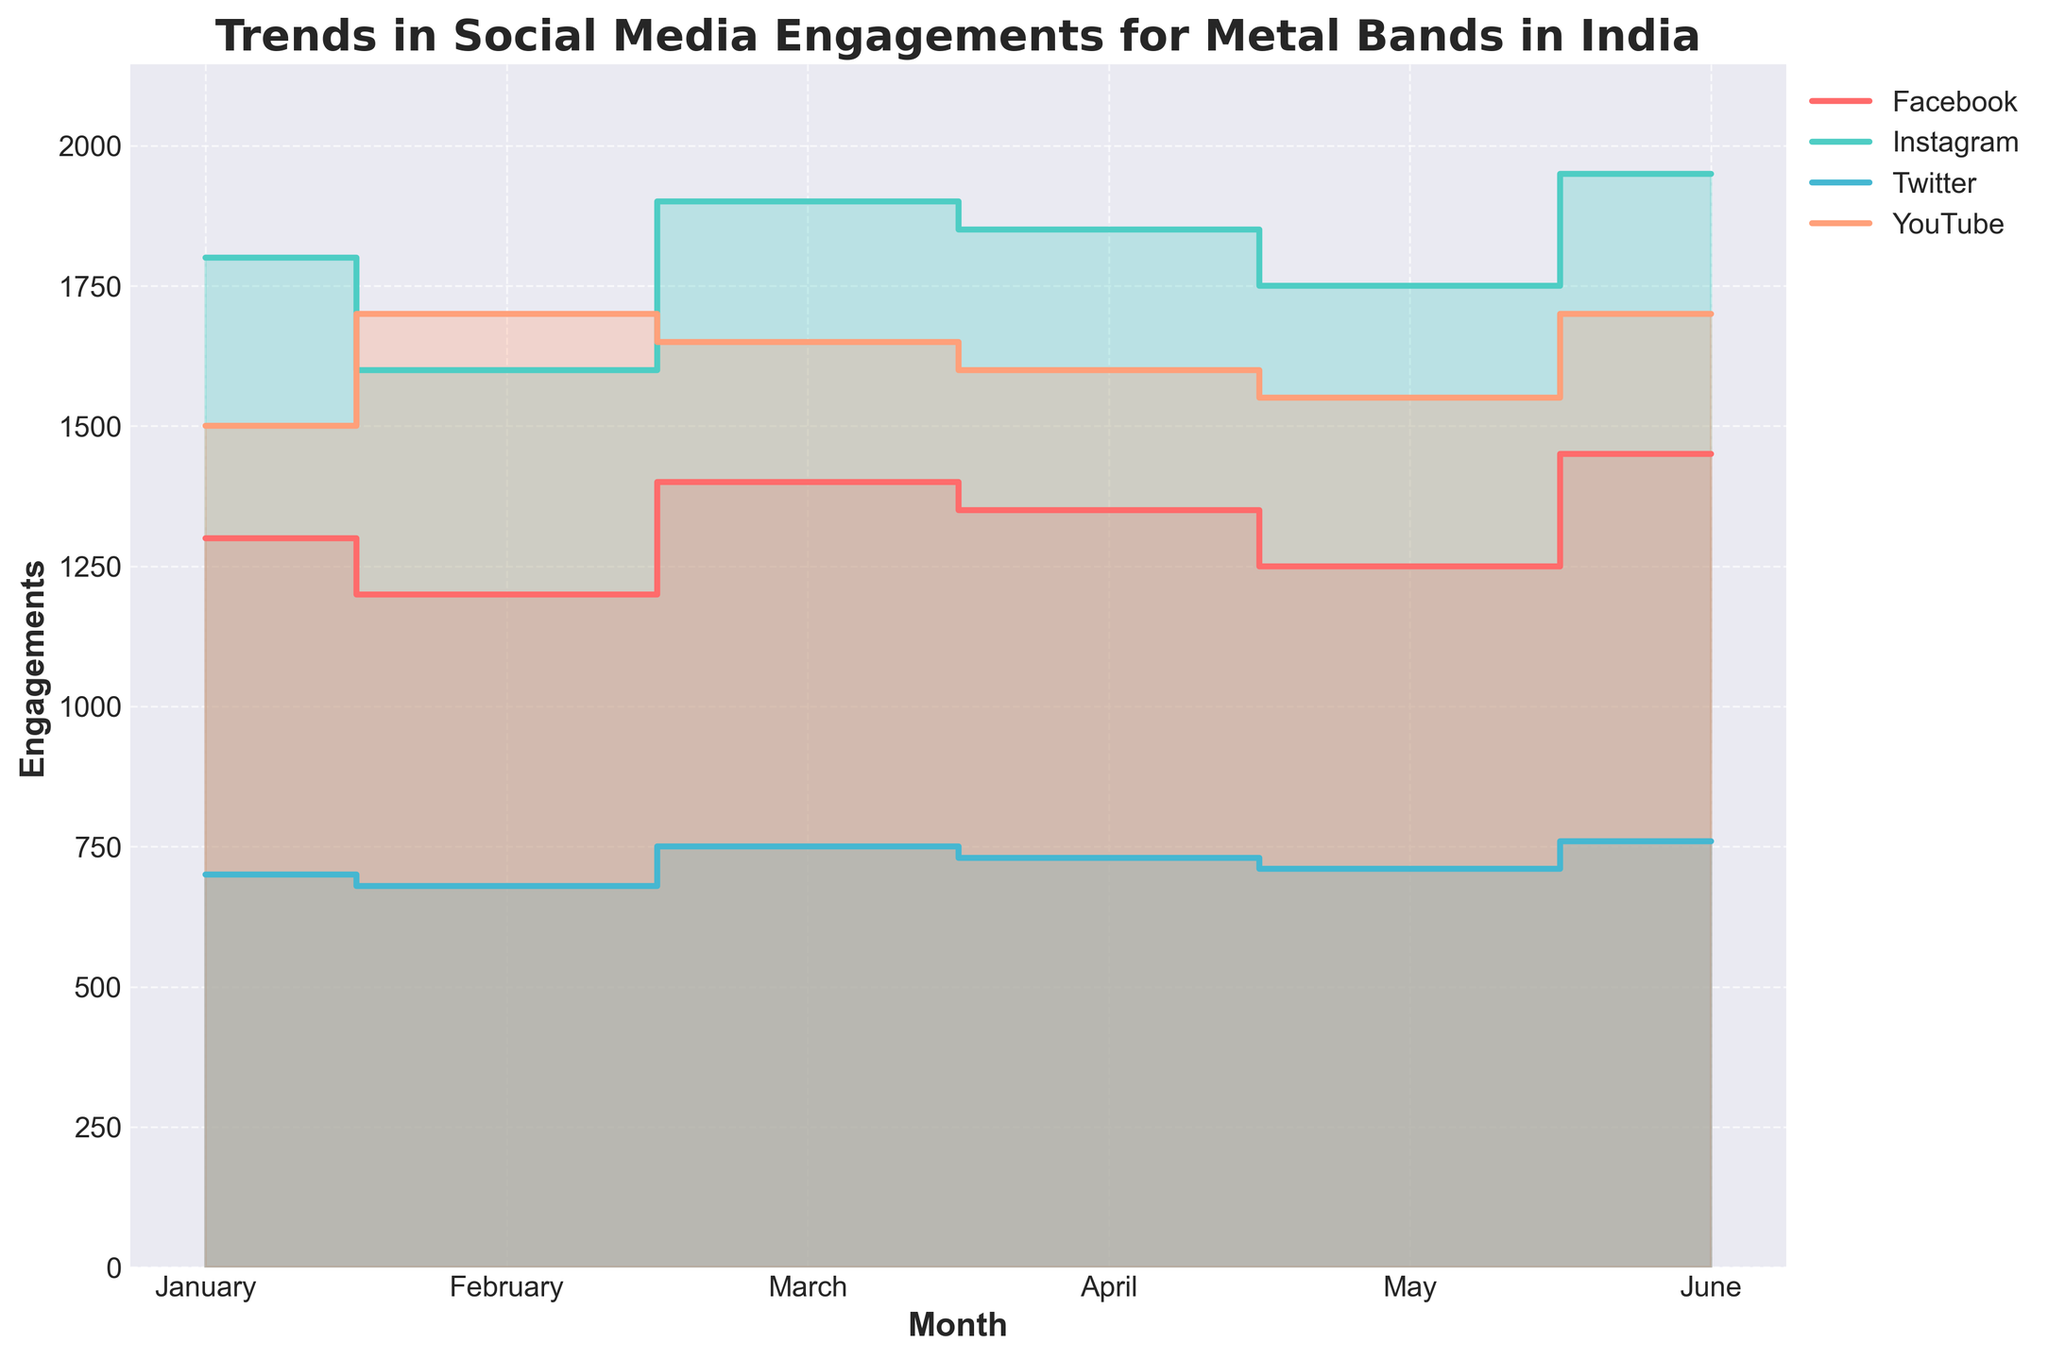What's the title of the figure? The title of the figure is located at the top and often provides a summary of what the figure represents. In this case, it says "Trends in Social Media Engagements for Metal Bands in India".
Answer: Trends in Social Media Engagements for Metal Bands in India Which platform had the highest engagement in June? By looking at the highest point in June for each platform, you can see that Instagram has the highest engagement.
Answer: Instagram How does the engagement on Twitter change from February to March? Observing the step area chart, the engagement on Twitter increases from 680 in February to 750 in March.
Answer: Increases What is the total engagement for Facebook in the first quarter (Jan to Mar)? Sum the engagement values for Facebook from January (1300), February (1200), and March (1400). (1300 + 1200 + 1400 = 3900)
Answer: 3900 Which platform shows an increasing trend in engagements from May to June? Check each platform's trend from May to June. Instagram shows an increase from 1750 to 1950 engagements.
Answer: Instagram Between March and April, which platform had the largest drop in engagements? By observing the step downs between March and April, Facebook drops from 1400 to 1350, and other platforms have smaller or no drops.
Answer: Facebook On which month did YouTube see its highest engagement? Looking at the peaks of the YouTube data, the highest engagement of 1700 is in June.
Answer: June Which platform had the smallest engagement value in any month? By comparing all the monthly engagement values across platforms, Twitter in February and May has the smallest engagements (680 and 710).
Answer: Twitter What is the average engagement for Instagram over the six months? Sum the engagement values for Instagram from January to June (1800 + 1600 + 1900 + 1850 + 1750 + 1950 = 10850), then divide by 6. (10850 / 6 = 1808.33)
Answer: 1808.33 Compare the trend of Twitter and YouTube from January to June. Twitter's engagements have a relatively flat or slight increase, while YouTube shows a more fluctuating trend with peaks in February and June.
Answer: Twitter: flat/small increase, YouTube: fluctuating 